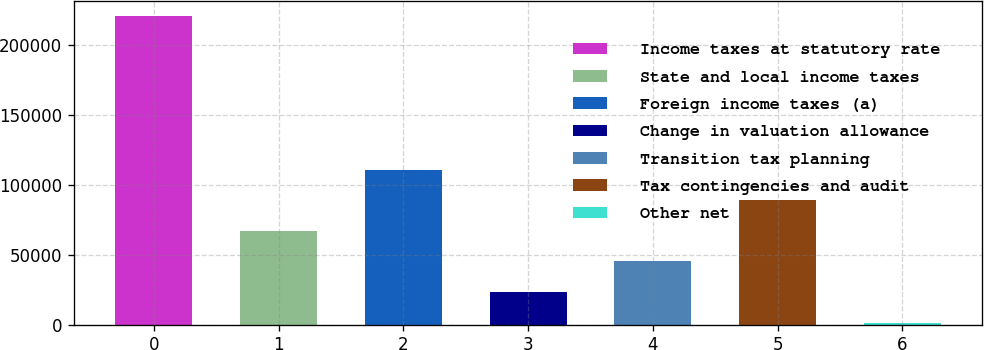<chart> <loc_0><loc_0><loc_500><loc_500><bar_chart><fcel>Income taxes at statutory rate<fcel>State and local income taxes<fcel>Foreign income taxes (a)<fcel>Change in valuation allowance<fcel>Transition tax planning<fcel>Tax contingencies and audit<fcel>Other net<nl><fcel>220332<fcel>67164.3<fcel>110926<fcel>23402.1<fcel>45283.2<fcel>89045.4<fcel>1521<nl></chart> 